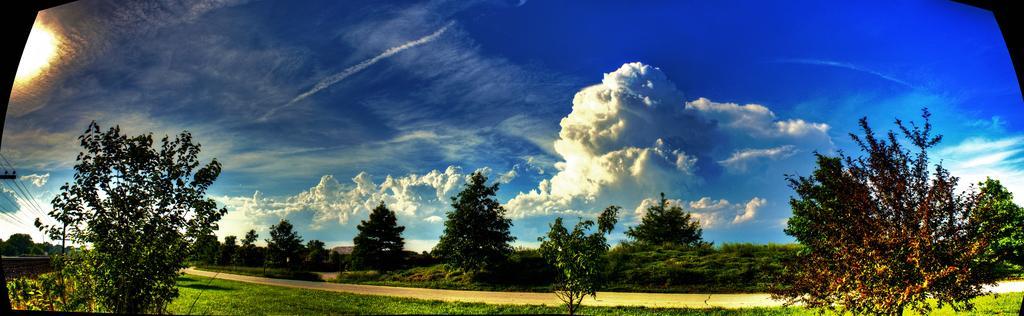Describe this image in one or two sentences. These are the trees. This is the grass. I think this looks like a road. These are the clouds in the sky. At the very left corner of the image, that looks like a current pole with current wires hanging. 